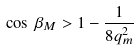Convert formula to latex. <formula><loc_0><loc_0><loc_500><loc_500>\cos \, \beta _ { M } > 1 - \frac { 1 } { 8 q _ { m } ^ { 2 } }</formula> 